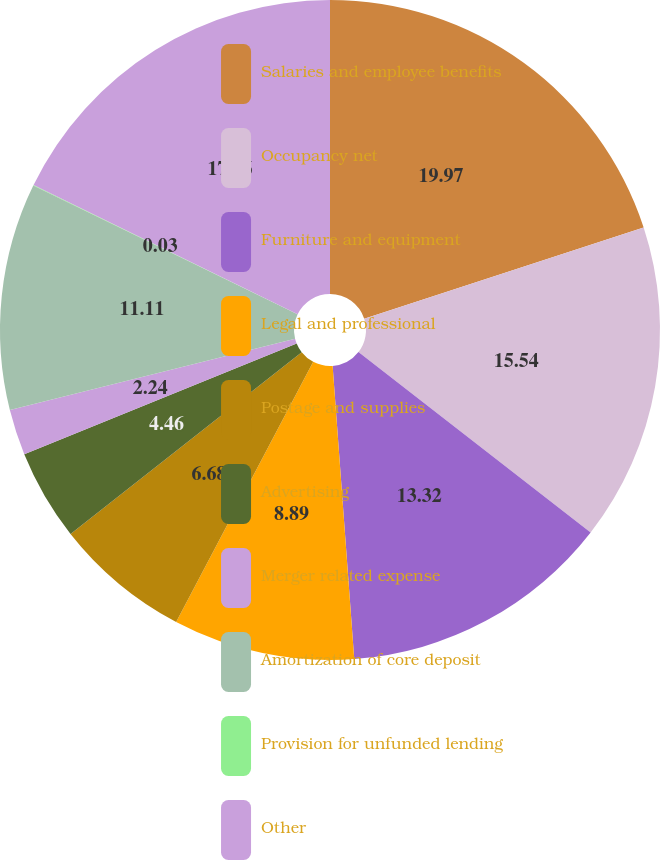<chart> <loc_0><loc_0><loc_500><loc_500><pie_chart><fcel>Salaries and employee benefits<fcel>Occupancy net<fcel>Furniture and equipment<fcel>Legal and professional<fcel>Postage and supplies<fcel>Advertising<fcel>Merger related expense<fcel>Amortization of core deposit<fcel>Provision for unfunded lending<fcel>Other<nl><fcel>19.97%<fcel>15.54%<fcel>13.32%<fcel>8.89%<fcel>6.68%<fcel>4.46%<fcel>2.24%<fcel>11.11%<fcel>0.03%<fcel>17.76%<nl></chart> 